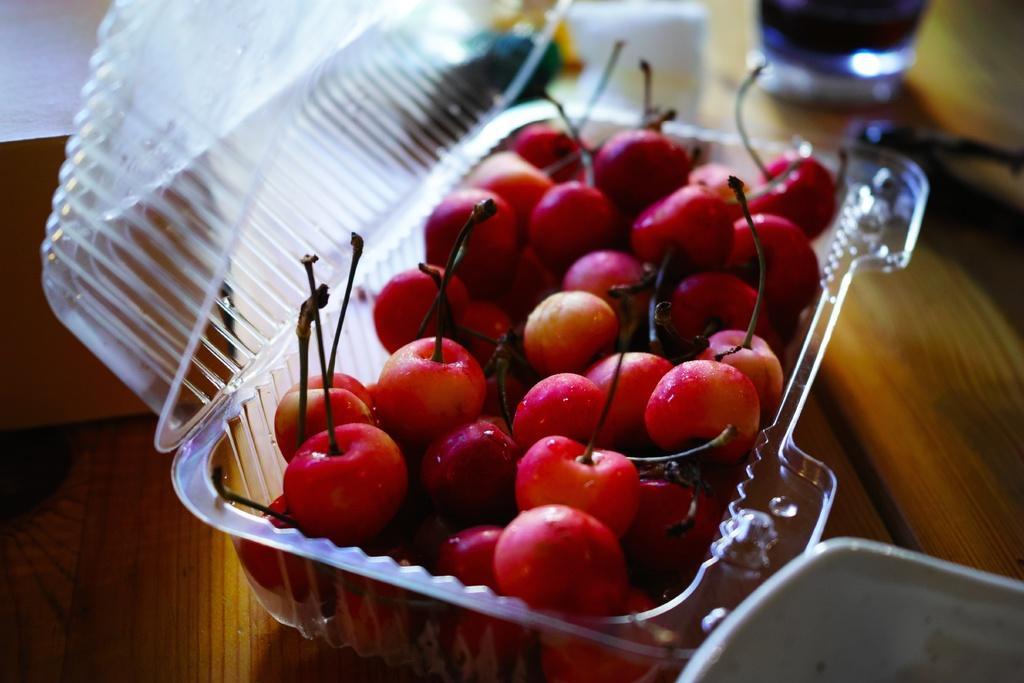Could you give a brief overview of what you see in this image? In this picture, we see a table on which bowl, a plastic box containing cherries, a glass containing liquid and pastry box are placed. 